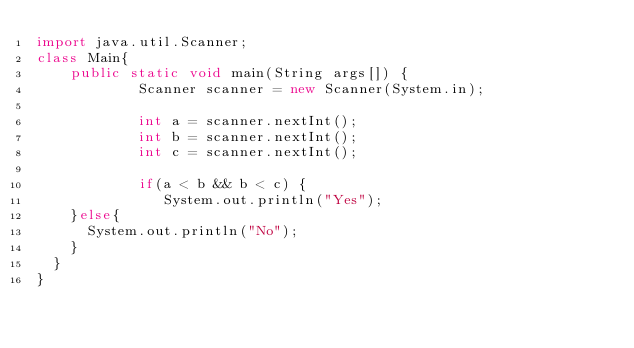<code> <loc_0><loc_0><loc_500><loc_500><_Java_>import java.util.Scanner;
class Main{
    public static void main(String args[]) {
            Scanner scanner = new Scanner(System.in);

            int a = scanner.nextInt();
            int b = scanner.nextInt();
            int c = scanner.nextInt();
            
            if(a < b && b < c) {
               System.out.println("Yes");
    }else{
      System.out.println("No");
    }
  }
}</code> 